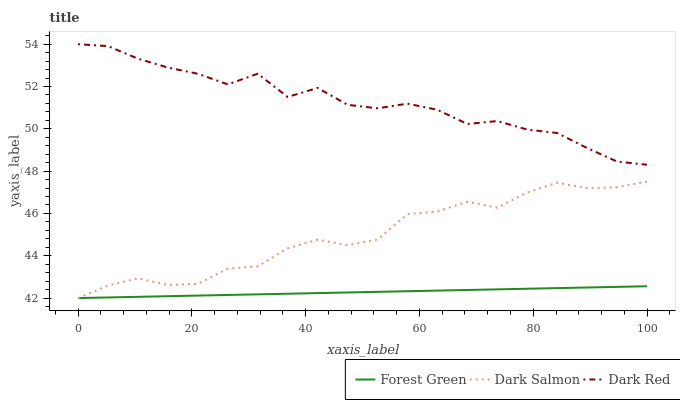Does Dark Salmon have the minimum area under the curve?
Answer yes or no. No. Does Dark Salmon have the maximum area under the curve?
Answer yes or no. No. Is Dark Salmon the smoothest?
Answer yes or no. No. Is Dark Salmon the roughest?
Answer yes or no. No. Does Dark Salmon have the highest value?
Answer yes or no. No. Is Forest Green less than Dark Red?
Answer yes or no. Yes. Is Dark Red greater than Dark Salmon?
Answer yes or no. Yes. Does Forest Green intersect Dark Red?
Answer yes or no. No. 